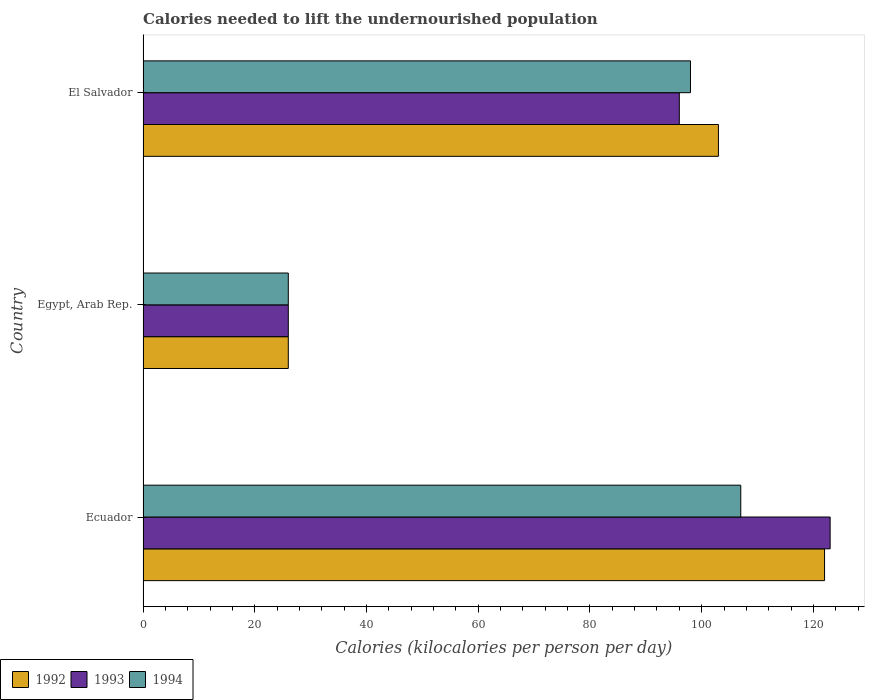Are the number of bars on each tick of the Y-axis equal?
Your response must be concise. Yes. How many bars are there on the 1st tick from the top?
Your answer should be compact. 3. What is the label of the 2nd group of bars from the top?
Make the answer very short. Egypt, Arab Rep. In how many cases, is the number of bars for a given country not equal to the number of legend labels?
Make the answer very short. 0. Across all countries, what is the maximum total calories needed to lift the undernourished population in 1994?
Offer a very short reply. 107. In which country was the total calories needed to lift the undernourished population in 1993 maximum?
Your answer should be very brief. Ecuador. In which country was the total calories needed to lift the undernourished population in 1994 minimum?
Make the answer very short. Egypt, Arab Rep. What is the total total calories needed to lift the undernourished population in 1992 in the graph?
Offer a very short reply. 251. What is the difference between the total calories needed to lift the undernourished population in 1993 in Egypt, Arab Rep. and that in El Salvador?
Your answer should be compact. -70. What is the average total calories needed to lift the undernourished population in 1994 per country?
Make the answer very short. 77. What is the difference between the total calories needed to lift the undernourished population in 1992 and total calories needed to lift the undernourished population in 1994 in Egypt, Arab Rep.?
Give a very brief answer. 0. In how many countries, is the total calories needed to lift the undernourished population in 1994 greater than 16 kilocalories?
Your answer should be very brief. 3. What is the ratio of the total calories needed to lift the undernourished population in 1993 in Ecuador to that in El Salvador?
Give a very brief answer. 1.28. What is the difference between the highest and the second highest total calories needed to lift the undernourished population in 1994?
Ensure brevity in your answer.  9. In how many countries, is the total calories needed to lift the undernourished population in 1993 greater than the average total calories needed to lift the undernourished population in 1993 taken over all countries?
Provide a succinct answer. 2. Is the sum of the total calories needed to lift the undernourished population in 1994 in Egypt, Arab Rep. and El Salvador greater than the maximum total calories needed to lift the undernourished population in 1993 across all countries?
Keep it short and to the point. Yes. What does the 1st bar from the bottom in Ecuador represents?
Make the answer very short. 1992. Is it the case that in every country, the sum of the total calories needed to lift the undernourished population in 1992 and total calories needed to lift the undernourished population in 1994 is greater than the total calories needed to lift the undernourished population in 1993?
Your answer should be very brief. Yes. Are all the bars in the graph horizontal?
Your answer should be very brief. Yes. Does the graph contain any zero values?
Your answer should be very brief. No. How many legend labels are there?
Your answer should be very brief. 3. How are the legend labels stacked?
Make the answer very short. Horizontal. What is the title of the graph?
Provide a succinct answer. Calories needed to lift the undernourished population. Does "1985" appear as one of the legend labels in the graph?
Your response must be concise. No. What is the label or title of the X-axis?
Your answer should be very brief. Calories (kilocalories per person per day). What is the Calories (kilocalories per person per day) of 1992 in Ecuador?
Keep it short and to the point. 122. What is the Calories (kilocalories per person per day) in 1993 in Ecuador?
Keep it short and to the point. 123. What is the Calories (kilocalories per person per day) of 1994 in Ecuador?
Give a very brief answer. 107. What is the Calories (kilocalories per person per day) in 1992 in El Salvador?
Your answer should be compact. 103. What is the Calories (kilocalories per person per day) in 1993 in El Salvador?
Offer a terse response. 96. Across all countries, what is the maximum Calories (kilocalories per person per day) of 1992?
Provide a succinct answer. 122. Across all countries, what is the maximum Calories (kilocalories per person per day) of 1993?
Provide a succinct answer. 123. Across all countries, what is the maximum Calories (kilocalories per person per day) in 1994?
Provide a succinct answer. 107. Across all countries, what is the minimum Calories (kilocalories per person per day) of 1992?
Your answer should be very brief. 26. Across all countries, what is the minimum Calories (kilocalories per person per day) in 1993?
Give a very brief answer. 26. What is the total Calories (kilocalories per person per day) in 1992 in the graph?
Give a very brief answer. 251. What is the total Calories (kilocalories per person per day) of 1993 in the graph?
Your answer should be very brief. 245. What is the total Calories (kilocalories per person per day) in 1994 in the graph?
Make the answer very short. 231. What is the difference between the Calories (kilocalories per person per day) of 1992 in Ecuador and that in Egypt, Arab Rep.?
Ensure brevity in your answer.  96. What is the difference between the Calories (kilocalories per person per day) in 1993 in Ecuador and that in Egypt, Arab Rep.?
Offer a very short reply. 97. What is the difference between the Calories (kilocalories per person per day) of 1994 in Ecuador and that in Egypt, Arab Rep.?
Make the answer very short. 81. What is the difference between the Calories (kilocalories per person per day) of 1992 in Ecuador and that in El Salvador?
Provide a short and direct response. 19. What is the difference between the Calories (kilocalories per person per day) in 1993 in Ecuador and that in El Salvador?
Offer a terse response. 27. What is the difference between the Calories (kilocalories per person per day) of 1994 in Ecuador and that in El Salvador?
Your answer should be very brief. 9. What is the difference between the Calories (kilocalories per person per day) of 1992 in Egypt, Arab Rep. and that in El Salvador?
Make the answer very short. -77. What is the difference between the Calories (kilocalories per person per day) of 1993 in Egypt, Arab Rep. and that in El Salvador?
Make the answer very short. -70. What is the difference between the Calories (kilocalories per person per day) of 1994 in Egypt, Arab Rep. and that in El Salvador?
Ensure brevity in your answer.  -72. What is the difference between the Calories (kilocalories per person per day) in 1992 in Ecuador and the Calories (kilocalories per person per day) in 1993 in Egypt, Arab Rep.?
Offer a very short reply. 96. What is the difference between the Calories (kilocalories per person per day) in 1992 in Ecuador and the Calories (kilocalories per person per day) in 1994 in Egypt, Arab Rep.?
Offer a terse response. 96. What is the difference between the Calories (kilocalories per person per day) in 1993 in Ecuador and the Calories (kilocalories per person per day) in 1994 in Egypt, Arab Rep.?
Keep it short and to the point. 97. What is the difference between the Calories (kilocalories per person per day) in 1993 in Ecuador and the Calories (kilocalories per person per day) in 1994 in El Salvador?
Provide a short and direct response. 25. What is the difference between the Calories (kilocalories per person per day) of 1992 in Egypt, Arab Rep. and the Calories (kilocalories per person per day) of 1993 in El Salvador?
Make the answer very short. -70. What is the difference between the Calories (kilocalories per person per day) in 1992 in Egypt, Arab Rep. and the Calories (kilocalories per person per day) in 1994 in El Salvador?
Your answer should be very brief. -72. What is the difference between the Calories (kilocalories per person per day) of 1993 in Egypt, Arab Rep. and the Calories (kilocalories per person per day) of 1994 in El Salvador?
Provide a succinct answer. -72. What is the average Calories (kilocalories per person per day) in 1992 per country?
Keep it short and to the point. 83.67. What is the average Calories (kilocalories per person per day) in 1993 per country?
Ensure brevity in your answer.  81.67. What is the average Calories (kilocalories per person per day) of 1994 per country?
Give a very brief answer. 77. What is the difference between the Calories (kilocalories per person per day) in 1992 and Calories (kilocalories per person per day) in 1993 in Ecuador?
Provide a short and direct response. -1. What is the difference between the Calories (kilocalories per person per day) of 1992 and Calories (kilocalories per person per day) of 1993 in Egypt, Arab Rep.?
Your answer should be very brief. 0. What is the difference between the Calories (kilocalories per person per day) in 1993 and Calories (kilocalories per person per day) in 1994 in Egypt, Arab Rep.?
Your answer should be very brief. 0. What is the ratio of the Calories (kilocalories per person per day) in 1992 in Ecuador to that in Egypt, Arab Rep.?
Your answer should be compact. 4.69. What is the ratio of the Calories (kilocalories per person per day) of 1993 in Ecuador to that in Egypt, Arab Rep.?
Your response must be concise. 4.73. What is the ratio of the Calories (kilocalories per person per day) in 1994 in Ecuador to that in Egypt, Arab Rep.?
Offer a very short reply. 4.12. What is the ratio of the Calories (kilocalories per person per day) in 1992 in Ecuador to that in El Salvador?
Your answer should be compact. 1.18. What is the ratio of the Calories (kilocalories per person per day) of 1993 in Ecuador to that in El Salvador?
Make the answer very short. 1.28. What is the ratio of the Calories (kilocalories per person per day) of 1994 in Ecuador to that in El Salvador?
Ensure brevity in your answer.  1.09. What is the ratio of the Calories (kilocalories per person per day) in 1992 in Egypt, Arab Rep. to that in El Salvador?
Provide a succinct answer. 0.25. What is the ratio of the Calories (kilocalories per person per day) of 1993 in Egypt, Arab Rep. to that in El Salvador?
Provide a short and direct response. 0.27. What is the ratio of the Calories (kilocalories per person per day) in 1994 in Egypt, Arab Rep. to that in El Salvador?
Offer a very short reply. 0.27. What is the difference between the highest and the second highest Calories (kilocalories per person per day) of 1992?
Your answer should be very brief. 19. What is the difference between the highest and the lowest Calories (kilocalories per person per day) of 1992?
Keep it short and to the point. 96. What is the difference between the highest and the lowest Calories (kilocalories per person per day) of 1993?
Make the answer very short. 97. 